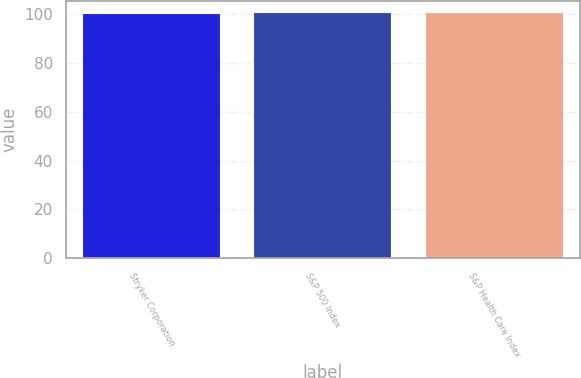Convert chart. <chart><loc_0><loc_0><loc_500><loc_500><bar_chart><fcel>Stryker Corporation<fcel>S&P 500 Index<fcel>S&P Health Care Index<nl><fcel>100<fcel>100.1<fcel>100.2<nl></chart> 